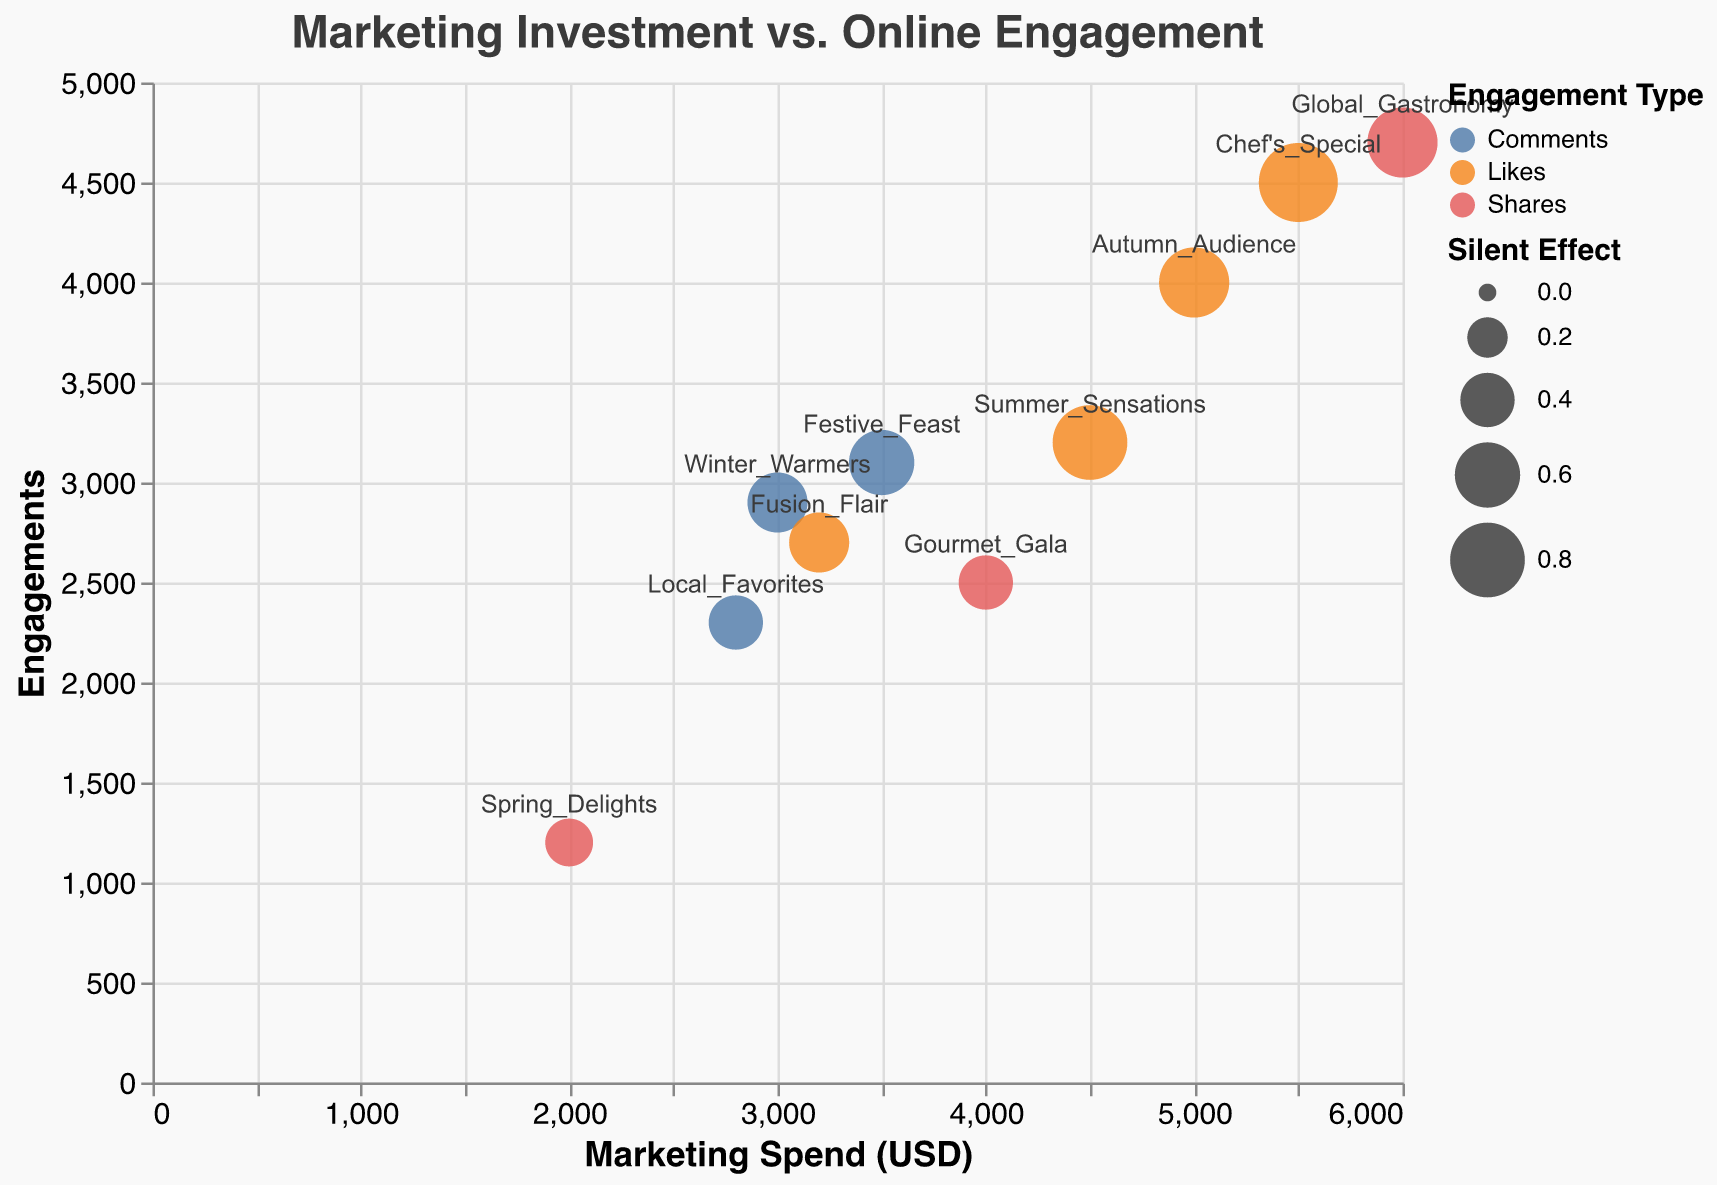What is the title of the chart? The title is located at the top of the chart, which summarizes the overall theme and purpose of the visualization. Here, it is clear and prominently positioned.
Answer: Marketing Investment vs. Online Engagement What is the average number of engagements for campaigns with a marketing spend above $4000? Identify the campaigns with marketing spends above $4000 (Summer Sensations, Autumn Audience, Chef's Special, Global Gastronomy). Sum their engagements (3200 + 4000 + 4500 + 4700 = 16400) and divide by the number of campaigns (4). The average is 16400/4.
Answer: 4100 Which campaign has the highest Silent Effect and what is its engagement value? Look for the largest bubble in the chart, which represents the highest Silent Effect value. From the data, the Campaign with the highest Silent Effect is Chef's Special with Silent Effect of 0.9. The engagement value for this campaign is 4500.
Answer: Chef's Special, 4500 Compare the engagements between campaigns that have the same engagement type but different marketing spend. Which of these campaigns have the most engagements? Look for campaigns sharing the same engagement type but differing in Marketing Spend. For instance, comparing "Likes" type: Summer Sensations ($4500 => 3200 engagements), Autumn Audience ($5000 => 4000 engagements), Chef's Special ($5500 => 4500 engagements), Fusion Flair ($3200 => 2700 engagements). Chef's Special has the highest engagements among these.
Answer: Chef's Special How does the number of engagements for ‘Festive Feast’ compare to ‘Winter Warmers’? Look at the engagement values for both campaigns. According to the data, Festive Feast has 3100 engagements, while Winter Warmers has 2900 engagements. Therefore, Festive Feast has more engagements than Winter Warmers.
Answer: Festive Feast has 200 more engagements than Winter Warmers Which campaign has the lowest marketing spend, and what engagement type does it have? Look for the smallest value on the Marketing Spend axis. The campaign with the lowest marketing spend is Spring Delights with a spend of $2000. The engagement type for this campaign is Shares.
Answer: Spring Delights, Shares Between 'Global Gastronomy' and 'Local Favorites', which campaign has a higher Silent Effect? Compare the size of the bubbles directly, as they represent the Silent Effect. From the data, Global Gastronomy has a Silent Effect of 0.7, while Local Favorites has a Silent Effect of 0.4. Thus, Global Gastronomy has a higher Silent Effect.
Answer: Global Gastronomy What is the total marketing spend for campaigns that received ‘Comments’ as the engagement type? Sum the marketing spend of campaigns where the engagement type is Comments. Winter Warmers ($3000) + Festive Feast ($3500) + Local Favorites ($2800) = $9300.
Answer: $9300 